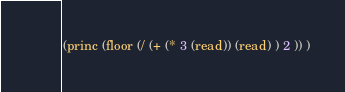<code> <loc_0><loc_0><loc_500><loc_500><_Lisp_>(princ (floor (/ (+ (* 3 (read)) (read) ) 2 )) )</code> 